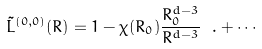<formula> <loc_0><loc_0><loc_500><loc_500>\tilde { L } ^ { ( 0 , 0 ) } ( R ) = 1 - \chi ( R _ { 0 } ) \frac { R _ { 0 } ^ { d - 3 } } { R ^ { d - 3 } } \ . + \cdots</formula> 